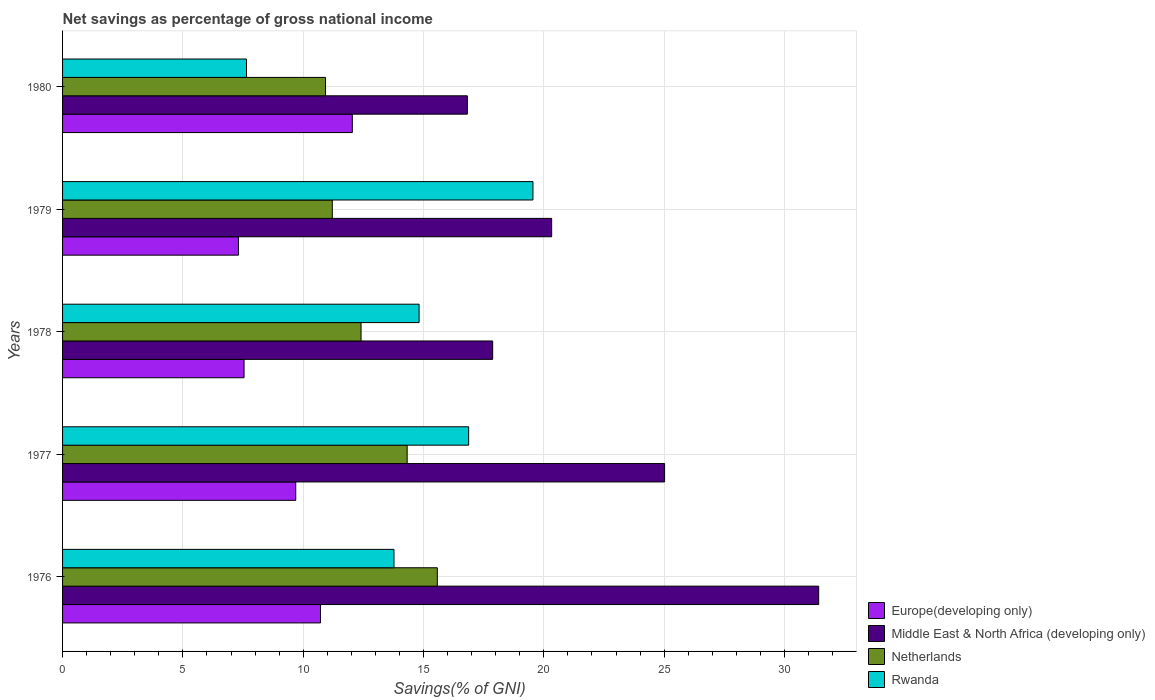How many groups of bars are there?
Make the answer very short. 5. Are the number of bars per tick equal to the number of legend labels?
Your response must be concise. Yes. Are the number of bars on each tick of the Y-axis equal?
Offer a very short reply. Yes. How many bars are there on the 1st tick from the top?
Provide a succinct answer. 4. What is the label of the 1st group of bars from the top?
Offer a terse response. 1980. In how many cases, is the number of bars for a given year not equal to the number of legend labels?
Ensure brevity in your answer.  0. What is the total savings in Middle East & North Africa (developing only) in 1977?
Offer a very short reply. 25.02. Across all years, what is the maximum total savings in Middle East & North Africa (developing only)?
Provide a short and direct response. 31.42. Across all years, what is the minimum total savings in Middle East & North Africa (developing only)?
Provide a succinct answer. 16.82. In which year was the total savings in Netherlands maximum?
Make the answer very short. 1976. In which year was the total savings in Europe(developing only) minimum?
Your answer should be very brief. 1979. What is the total total savings in Middle East & North Africa (developing only) in the graph?
Give a very brief answer. 111.46. What is the difference between the total savings in Middle East & North Africa (developing only) in 1977 and that in 1978?
Your answer should be compact. 7.14. What is the difference between the total savings in Europe(developing only) in 1979 and the total savings in Rwanda in 1980?
Offer a very short reply. -0.33. What is the average total savings in Netherlands per year?
Your answer should be very brief. 12.89. In the year 1978, what is the difference between the total savings in Middle East & North Africa (developing only) and total savings in Netherlands?
Your answer should be very brief. 5.47. What is the ratio of the total savings in Europe(developing only) in 1977 to that in 1978?
Provide a short and direct response. 1.28. Is the difference between the total savings in Middle East & North Africa (developing only) in 1976 and 1979 greater than the difference between the total savings in Netherlands in 1976 and 1979?
Your answer should be compact. Yes. What is the difference between the highest and the second highest total savings in Rwanda?
Your response must be concise. 2.67. What is the difference between the highest and the lowest total savings in Europe(developing only)?
Make the answer very short. 4.73. In how many years, is the total savings in Middle East & North Africa (developing only) greater than the average total savings in Middle East & North Africa (developing only) taken over all years?
Offer a terse response. 2. Is it the case that in every year, the sum of the total savings in Rwanda and total savings in Europe(developing only) is greater than the sum of total savings in Middle East & North Africa (developing only) and total savings in Netherlands?
Offer a very short reply. No. What does the 1st bar from the top in 1977 represents?
Your answer should be very brief. Rwanda. What does the 2nd bar from the bottom in 1978 represents?
Give a very brief answer. Middle East & North Africa (developing only). Is it the case that in every year, the sum of the total savings in Middle East & North Africa (developing only) and total savings in Rwanda is greater than the total savings in Netherlands?
Your answer should be very brief. Yes. Are all the bars in the graph horizontal?
Your answer should be compact. Yes. How many legend labels are there?
Offer a terse response. 4. What is the title of the graph?
Offer a terse response. Net savings as percentage of gross national income. What is the label or title of the X-axis?
Keep it short and to the point. Savings(% of GNI). What is the Savings(% of GNI) of Europe(developing only) in 1976?
Your response must be concise. 10.72. What is the Savings(% of GNI) of Middle East & North Africa (developing only) in 1976?
Ensure brevity in your answer.  31.42. What is the Savings(% of GNI) of Netherlands in 1976?
Your response must be concise. 15.57. What is the Savings(% of GNI) in Rwanda in 1976?
Provide a short and direct response. 13.77. What is the Savings(% of GNI) of Europe(developing only) in 1977?
Make the answer very short. 9.69. What is the Savings(% of GNI) in Middle East & North Africa (developing only) in 1977?
Provide a short and direct response. 25.02. What is the Savings(% of GNI) in Netherlands in 1977?
Your answer should be very brief. 14.32. What is the Savings(% of GNI) in Rwanda in 1977?
Your answer should be very brief. 16.88. What is the Savings(% of GNI) in Europe(developing only) in 1978?
Ensure brevity in your answer.  7.54. What is the Savings(% of GNI) in Middle East & North Africa (developing only) in 1978?
Keep it short and to the point. 17.87. What is the Savings(% of GNI) in Netherlands in 1978?
Your answer should be compact. 12.4. What is the Savings(% of GNI) in Rwanda in 1978?
Your response must be concise. 14.82. What is the Savings(% of GNI) in Europe(developing only) in 1979?
Offer a terse response. 7.31. What is the Savings(% of GNI) of Middle East & North Africa (developing only) in 1979?
Ensure brevity in your answer.  20.32. What is the Savings(% of GNI) in Netherlands in 1979?
Provide a succinct answer. 11.21. What is the Savings(% of GNI) in Rwanda in 1979?
Make the answer very short. 19.55. What is the Savings(% of GNI) in Europe(developing only) in 1980?
Your response must be concise. 12.04. What is the Savings(% of GNI) in Middle East & North Africa (developing only) in 1980?
Offer a very short reply. 16.82. What is the Savings(% of GNI) of Netherlands in 1980?
Keep it short and to the point. 10.93. What is the Savings(% of GNI) of Rwanda in 1980?
Make the answer very short. 7.64. Across all years, what is the maximum Savings(% of GNI) of Europe(developing only)?
Your answer should be compact. 12.04. Across all years, what is the maximum Savings(% of GNI) in Middle East & North Africa (developing only)?
Provide a succinct answer. 31.42. Across all years, what is the maximum Savings(% of GNI) in Netherlands?
Your answer should be very brief. 15.57. Across all years, what is the maximum Savings(% of GNI) of Rwanda?
Make the answer very short. 19.55. Across all years, what is the minimum Savings(% of GNI) of Europe(developing only)?
Keep it short and to the point. 7.31. Across all years, what is the minimum Savings(% of GNI) of Middle East & North Africa (developing only)?
Offer a terse response. 16.82. Across all years, what is the minimum Savings(% of GNI) of Netherlands?
Keep it short and to the point. 10.93. Across all years, what is the minimum Savings(% of GNI) in Rwanda?
Offer a terse response. 7.64. What is the total Savings(% of GNI) in Europe(developing only) in the graph?
Keep it short and to the point. 47.3. What is the total Savings(% of GNI) in Middle East & North Africa (developing only) in the graph?
Offer a very short reply. 111.46. What is the total Savings(% of GNI) of Netherlands in the graph?
Your response must be concise. 64.43. What is the total Savings(% of GNI) of Rwanda in the graph?
Your response must be concise. 72.66. What is the difference between the Savings(% of GNI) of Europe(developing only) in 1976 and that in 1977?
Your answer should be very brief. 1.03. What is the difference between the Savings(% of GNI) of Middle East & North Africa (developing only) in 1976 and that in 1977?
Keep it short and to the point. 6.4. What is the difference between the Savings(% of GNI) in Netherlands in 1976 and that in 1977?
Make the answer very short. 1.25. What is the difference between the Savings(% of GNI) in Rwanda in 1976 and that in 1977?
Your answer should be very brief. -3.1. What is the difference between the Savings(% of GNI) in Europe(developing only) in 1976 and that in 1978?
Keep it short and to the point. 3.18. What is the difference between the Savings(% of GNI) in Middle East & North Africa (developing only) in 1976 and that in 1978?
Provide a succinct answer. 13.55. What is the difference between the Savings(% of GNI) of Netherlands in 1976 and that in 1978?
Provide a short and direct response. 3.17. What is the difference between the Savings(% of GNI) in Rwanda in 1976 and that in 1978?
Provide a short and direct response. -1.04. What is the difference between the Savings(% of GNI) in Europe(developing only) in 1976 and that in 1979?
Make the answer very short. 3.41. What is the difference between the Savings(% of GNI) in Middle East & North Africa (developing only) in 1976 and that in 1979?
Provide a short and direct response. 11.1. What is the difference between the Savings(% of GNI) of Netherlands in 1976 and that in 1979?
Your response must be concise. 4.36. What is the difference between the Savings(% of GNI) in Rwanda in 1976 and that in 1979?
Ensure brevity in your answer.  -5.77. What is the difference between the Savings(% of GNI) in Europe(developing only) in 1976 and that in 1980?
Give a very brief answer. -1.32. What is the difference between the Savings(% of GNI) in Middle East & North Africa (developing only) in 1976 and that in 1980?
Provide a short and direct response. 14.6. What is the difference between the Savings(% of GNI) in Netherlands in 1976 and that in 1980?
Offer a terse response. 4.65. What is the difference between the Savings(% of GNI) in Rwanda in 1976 and that in 1980?
Provide a short and direct response. 6.13. What is the difference between the Savings(% of GNI) of Europe(developing only) in 1977 and that in 1978?
Keep it short and to the point. 2.15. What is the difference between the Savings(% of GNI) of Middle East & North Africa (developing only) in 1977 and that in 1978?
Offer a terse response. 7.14. What is the difference between the Savings(% of GNI) of Netherlands in 1977 and that in 1978?
Your answer should be very brief. 1.92. What is the difference between the Savings(% of GNI) of Rwanda in 1977 and that in 1978?
Give a very brief answer. 2.06. What is the difference between the Savings(% of GNI) of Europe(developing only) in 1977 and that in 1979?
Ensure brevity in your answer.  2.38. What is the difference between the Savings(% of GNI) of Middle East & North Africa (developing only) in 1977 and that in 1979?
Your answer should be compact. 4.69. What is the difference between the Savings(% of GNI) of Netherlands in 1977 and that in 1979?
Provide a succinct answer. 3.11. What is the difference between the Savings(% of GNI) of Rwanda in 1977 and that in 1979?
Make the answer very short. -2.67. What is the difference between the Savings(% of GNI) of Europe(developing only) in 1977 and that in 1980?
Your response must be concise. -2.35. What is the difference between the Savings(% of GNI) in Middle East & North Africa (developing only) in 1977 and that in 1980?
Your answer should be compact. 8.2. What is the difference between the Savings(% of GNI) in Netherlands in 1977 and that in 1980?
Your response must be concise. 3.39. What is the difference between the Savings(% of GNI) of Rwanda in 1977 and that in 1980?
Offer a terse response. 9.23. What is the difference between the Savings(% of GNI) of Europe(developing only) in 1978 and that in 1979?
Keep it short and to the point. 0.23. What is the difference between the Savings(% of GNI) of Middle East & North Africa (developing only) in 1978 and that in 1979?
Offer a terse response. -2.45. What is the difference between the Savings(% of GNI) in Netherlands in 1978 and that in 1979?
Offer a terse response. 1.19. What is the difference between the Savings(% of GNI) of Rwanda in 1978 and that in 1979?
Give a very brief answer. -4.73. What is the difference between the Savings(% of GNI) of Europe(developing only) in 1978 and that in 1980?
Offer a very short reply. -4.5. What is the difference between the Savings(% of GNI) of Middle East & North Africa (developing only) in 1978 and that in 1980?
Give a very brief answer. 1.05. What is the difference between the Savings(% of GNI) in Netherlands in 1978 and that in 1980?
Your response must be concise. 1.48. What is the difference between the Savings(% of GNI) in Rwanda in 1978 and that in 1980?
Provide a succinct answer. 7.17. What is the difference between the Savings(% of GNI) in Europe(developing only) in 1979 and that in 1980?
Your response must be concise. -4.73. What is the difference between the Savings(% of GNI) in Middle East & North Africa (developing only) in 1979 and that in 1980?
Offer a very short reply. 3.5. What is the difference between the Savings(% of GNI) in Netherlands in 1979 and that in 1980?
Give a very brief answer. 0.28. What is the difference between the Savings(% of GNI) in Rwanda in 1979 and that in 1980?
Provide a succinct answer. 11.9. What is the difference between the Savings(% of GNI) of Europe(developing only) in 1976 and the Savings(% of GNI) of Middle East & North Africa (developing only) in 1977?
Offer a terse response. -14.3. What is the difference between the Savings(% of GNI) in Europe(developing only) in 1976 and the Savings(% of GNI) in Netherlands in 1977?
Offer a terse response. -3.6. What is the difference between the Savings(% of GNI) in Europe(developing only) in 1976 and the Savings(% of GNI) in Rwanda in 1977?
Your answer should be very brief. -6.16. What is the difference between the Savings(% of GNI) of Middle East & North Africa (developing only) in 1976 and the Savings(% of GNI) of Netherlands in 1977?
Your answer should be compact. 17.1. What is the difference between the Savings(% of GNI) in Middle East & North Africa (developing only) in 1976 and the Savings(% of GNI) in Rwanda in 1977?
Your answer should be compact. 14.55. What is the difference between the Savings(% of GNI) in Netherlands in 1976 and the Savings(% of GNI) in Rwanda in 1977?
Make the answer very short. -1.3. What is the difference between the Savings(% of GNI) of Europe(developing only) in 1976 and the Savings(% of GNI) of Middle East & North Africa (developing only) in 1978?
Provide a short and direct response. -7.15. What is the difference between the Savings(% of GNI) in Europe(developing only) in 1976 and the Savings(% of GNI) in Netherlands in 1978?
Your answer should be very brief. -1.68. What is the difference between the Savings(% of GNI) of Europe(developing only) in 1976 and the Savings(% of GNI) of Rwanda in 1978?
Provide a short and direct response. -4.1. What is the difference between the Savings(% of GNI) of Middle East & North Africa (developing only) in 1976 and the Savings(% of GNI) of Netherlands in 1978?
Make the answer very short. 19.02. What is the difference between the Savings(% of GNI) in Middle East & North Africa (developing only) in 1976 and the Savings(% of GNI) in Rwanda in 1978?
Keep it short and to the point. 16.61. What is the difference between the Savings(% of GNI) in Netherlands in 1976 and the Savings(% of GNI) in Rwanda in 1978?
Provide a succinct answer. 0.76. What is the difference between the Savings(% of GNI) in Europe(developing only) in 1976 and the Savings(% of GNI) in Middle East & North Africa (developing only) in 1979?
Give a very brief answer. -9.6. What is the difference between the Savings(% of GNI) of Europe(developing only) in 1976 and the Savings(% of GNI) of Netherlands in 1979?
Offer a terse response. -0.49. What is the difference between the Savings(% of GNI) of Europe(developing only) in 1976 and the Savings(% of GNI) of Rwanda in 1979?
Give a very brief answer. -8.83. What is the difference between the Savings(% of GNI) of Middle East & North Africa (developing only) in 1976 and the Savings(% of GNI) of Netherlands in 1979?
Offer a terse response. 20.21. What is the difference between the Savings(% of GNI) of Middle East & North Africa (developing only) in 1976 and the Savings(% of GNI) of Rwanda in 1979?
Keep it short and to the point. 11.87. What is the difference between the Savings(% of GNI) in Netherlands in 1976 and the Savings(% of GNI) in Rwanda in 1979?
Provide a short and direct response. -3.97. What is the difference between the Savings(% of GNI) of Europe(developing only) in 1976 and the Savings(% of GNI) of Middle East & North Africa (developing only) in 1980?
Your answer should be compact. -6.1. What is the difference between the Savings(% of GNI) in Europe(developing only) in 1976 and the Savings(% of GNI) in Netherlands in 1980?
Your answer should be very brief. -0.21. What is the difference between the Savings(% of GNI) in Europe(developing only) in 1976 and the Savings(% of GNI) in Rwanda in 1980?
Your answer should be compact. 3.08. What is the difference between the Savings(% of GNI) of Middle East & North Africa (developing only) in 1976 and the Savings(% of GNI) of Netherlands in 1980?
Ensure brevity in your answer.  20.49. What is the difference between the Savings(% of GNI) of Middle East & North Africa (developing only) in 1976 and the Savings(% of GNI) of Rwanda in 1980?
Ensure brevity in your answer.  23.78. What is the difference between the Savings(% of GNI) in Netherlands in 1976 and the Savings(% of GNI) in Rwanda in 1980?
Provide a succinct answer. 7.93. What is the difference between the Savings(% of GNI) in Europe(developing only) in 1977 and the Savings(% of GNI) in Middle East & North Africa (developing only) in 1978?
Provide a succinct answer. -8.18. What is the difference between the Savings(% of GNI) of Europe(developing only) in 1977 and the Savings(% of GNI) of Netherlands in 1978?
Keep it short and to the point. -2.71. What is the difference between the Savings(% of GNI) in Europe(developing only) in 1977 and the Savings(% of GNI) in Rwanda in 1978?
Offer a very short reply. -5.13. What is the difference between the Savings(% of GNI) of Middle East & North Africa (developing only) in 1977 and the Savings(% of GNI) of Netherlands in 1978?
Offer a terse response. 12.62. What is the difference between the Savings(% of GNI) of Middle East & North Africa (developing only) in 1977 and the Savings(% of GNI) of Rwanda in 1978?
Keep it short and to the point. 10.2. What is the difference between the Savings(% of GNI) of Netherlands in 1977 and the Savings(% of GNI) of Rwanda in 1978?
Keep it short and to the point. -0.5. What is the difference between the Savings(% of GNI) in Europe(developing only) in 1977 and the Savings(% of GNI) in Middle East & North Africa (developing only) in 1979?
Offer a very short reply. -10.63. What is the difference between the Savings(% of GNI) of Europe(developing only) in 1977 and the Savings(% of GNI) of Netherlands in 1979?
Provide a succinct answer. -1.52. What is the difference between the Savings(% of GNI) of Europe(developing only) in 1977 and the Savings(% of GNI) of Rwanda in 1979?
Offer a terse response. -9.86. What is the difference between the Savings(% of GNI) in Middle East & North Africa (developing only) in 1977 and the Savings(% of GNI) in Netherlands in 1979?
Provide a succinct answer. 13.81. What is the difference between the Savings(% of GNI) in Middle East & North Africa (developing only) in 1977 and the Savings(% of GNI) in Rwanda in 1979?
Your answer should be very brief. 5.47. What is the difference between the Savings(% of GNI) in Netherlands in 1977 and the Savings(% of GNI) in Rwanda in 1979?
Keep it short and to the point. -5.23. What is the difference between the Savings(% of GNI) of Europe(developing only) in 1977 and the Savings(% of GNI) of Middle East & North Africa (developing only) in 1980?
Give a very brief answer. -7.13. What is the difference between the Savings(% of GNI) of Europe(developing only) in 1977 and the Savings(% of GNI) of Netherlands in 1980?
Your response must be concise. -1.24. What is the difference between the Savings(% of GNI) of Europe(developing only) in 1977 and the Savings(% of GNI) of Rwanda in 1980?
Your answer should be very brief. 2.05. What is the difference between the Savings(% of GNI) of Middle East & North Africa (developing only) in 1977 and the Savings(% of GNI) of Netherlands in 1980?
Offer a terse response. 14.09. What is the difference between the Savings(% of GNI) in Middle East & North Africa (developing only) in 1977 and the Savings(% of GNI) in Rwanda in 1980?
Give a very brief answer. 17.37. What is the difference between the Savings(% of GNI) of Netherlands in 1977 and the Savings(% of GNI) of Rwanda in 1980?
Your answer should be compact. 6.68. What is the difference between the Savings(% of GNI) of Europe(developing only) in 1978 and the Savings(% of GNI) of Middle East & North Africa (developing only) in 1979?
Give a very brief answer. -12.78. What is the difference between the Savings(% of GNI) in Europe(developing only) in 1978 and the Savings(% of GNI) in Netherlands in 1979?
Your answer should be very brief. -3.67. What is the difference between the Savings(% of GNI) in Europe(developing only) in 1978 and the Savings(% of GNI) in Rwanda in 1979?
Make the answer very short. -12.01. What is the difference between the Savings(% of GNI) of Middle East & North Africa (developing only) in 1978 and the Savings(% of GNI) of Netherlands in 1979?
Give a very brief answer. 6.66. What is the difference between the Savings(% of GNI) in Middle East & North Africa (developing only) in 1978 and the Savings(% of GNI) in Rwanda in 1979?
Provide a succinct answer. -1.67. What is the difference between the Savings(% of GNI) of Netherlands in 1978 and the Savings(% of GNI) of Rwanda in 1979?
Provide a succinct answer. -7.14. What is the difference between the Savings(% of GNI) in Europe(developing only) in 1978 and the Savings(% of GNI) in Middle East & North Africa (developing only) in 1980?
Offer a terse response. -9.28. What is the difference between the Savings(% of GNI) of Europe(developing only) in 1978 and the Savings(% of GNI) of Netherlands in 1980?
Give a very brief answer. -3.39. What is the difference between the Savings(% of GNI) in Europe(developing only) in 1978 and the Savings(% of GNI) in Rwanda in 1980?
Keep it short and to the point. -0.1. What is the difference between the Savings(% of GNI) in Middle East & North Africa (developing only) in 1978 and the Savings(% of GNI) in Netherlands in 1980?
Your response must be concise. 6.95. What is the difference between the Savings(% of GNI) of Middle East & North Africa (developing only) in 1978 and the Savings(% of GNI) of Rwanda in 1980?
Make the answer very short. 10.23. What is the difference between the Savings(% of GNI) of Netherlands in 1978 and the Savings(% of GNI) of Rwanda in 1980?
Offer a very short reply. 4.76. What is the difference between the Savings(% of GNI) in Europe(developing only) in 1979 and the Savings(% of GNI) in Middle East & North Africa (developing only) in 1980?
Keep it short and to the point. -9.51. What is the difference between the Savings(% of GNI) of Europe(developing only) in 1979 and the Savings(% of GNI) of Netherlands in 1980?
Your response must be concise. -3.62. What is the difference between the Savings(% of GNI) in Europe(developing only) in 1979 and the Savings(% of GNI) in Rwanda in 1980?
Give a very brief answer. -0.33. What is the difference between the Savings(% of GNI) of Middle East & North Africa (developing only) in 1979 and the Savings(% of GNI) of Netherlands in 1980?
Your answer should be compact. 9.4. What is the difference between the Savings(% of GNI) of Middle East & North Africa (developing only) in 1979 and the Savings(% of GNI) of Rwanda in 1980?
Ensure brevity in your answer.  12.68. What is the difference between the Savings(% of GNI) in Netherlands in 1979 and the Savings(% of GNI) in Rwanda in 1980?
Offer a very short reply. 3.57. What is the average Savings(% of GNI) of Europe(developing only) per year?
Provide a succinct answer. 9.46. What is the average Savings(% of GNI) in Middle East & North Africa (developing only) per year?
Give a very brief answer. 22.29. What is the average Savings(% of GNI) in Netherlands per year?
Your answer should be very brief. 12.89. What is the average Savings(% of GNI) of Rwanda per year?
Keep it short and to the point. 14.53. In the year 1976, what is the difference between the Savings(% of GNI) in Europe(developing only) and Savings(% of GNI) in Middle East & North Africa (developing only)?
Ensure brevity in your answer.  -20.7. In the year 1976, what is the difference between the Savings(% of GNI) of Europe(developing only) and Savings(% of GNI) of Netherlands?
Your answer should be compact. -4.85. In the year 1976, what is the difference between the Savings(% of GNI) in Europe(developing only) and Savings(% of GNI) in Rwanda?
Your answer should be very brief. -3.05. In the year 1976, what is the difference between the Savings(% of GNI) of Middle East & North Africa (developing only) and Savings(% of GNI) of Netherlands?
Your response must be concise. 15.85. In the year 1976, what is the difference between the Savings(% of GNI) of Middle East & North Africa (developing only) and Savings(% of GNI) of Rwanda?
Keep it short and to the point. 17.65. In the year 1976, what is the difference between the Savings(% of GNI) in Netherlands and Savings(% of GNI) in Rwanda?
Offer a terse response. 1.8. In the year 1977, what is the difference between the Savings(% of GNI) in Europe(developing only) and Savings(% of GNI) in Middle East & North Africa (developing only)?
Your response must be concise. -15.33. In the year 1977, what is the difference between the Savings(% of GNI) of Europe(developing only) and Savings(% of GNI) of Netherlands?
Your answer should be very brief. -4.63. In the year 1977, what is the difference between the Savings(% of GNI) in Europe(developing only) and Savings(% of GNI) in Rwanda?
Keep it short and to the point. -7.18. In the year 1977, what is the difference between the Savings(% of GNI) in Middle East & North Africa (developing only) and Savings(% of GNI) in Netherlands?
Provide a short and direct response. 10.7. In the year 1977, what is the difference between the Savings(% of GNI) of Middle East & North Africa (developing only) and Savings(% of GNI) of Rwanda?
Provide a short and direct response. 8.14. In the year 1977, what is the difference between the Savings(% of GNI) in Netherlands and Savings(% of GNI) in Rwanda?
Provide a short and direct response. -2.56. In the year 1978, what is the difference between the Savings(% of GNI) in Europe(developing only) and Savings(% of GNI) in Middle East & North Africa (developing only)?
Offer a terse response. -10.33. In the year 1978, what is the difference between the Savings(% of GNI) of Europe(developing only) and Savings(% of GNI) of Netherlands?
Your answer should be compact. -4.86. In the year 1978, what is the difference between the Savings(% of GNI) of Europe(developing only) and Savings(% of GNI) of Rwanda?
Ensure brevity in your answer.  -7.27. In the year 1978, what is the difference between the Savings(% of GNI) in Middle East & North Africa (developing only) and Savings(% of GNI) in Netherlands?
Provide a succinct answer. 5.47. In the year 1978, what is the difference between the Savings(% of GNI) of Middle East & North Africa (developing only) and Savings(% of GNI) of Rwanda?
Give a very brief answer. 3.06. In the year 1978, what is the difference between the Savings(% of GNI) in Netherlands and Savings(% of GNI) in Rwanda?
Provide a short and direct response. -2.41. In the year 1979, what is the difference between the Savings(% of GNI) in Europe(developing only) and Savings(% of GNI) in Middle East & North Africa (developing only)?
Provide a short and direct response. -13.02. In the year 1979, what is the difference between the Savings(% of GNI) in Europe(developing only) and Savings(% of GNI) in Netherlands?
Ensure brevity in your answer.  -3.9. In the year 1979, what is the difference between the Savings(% of GNI) of Europe(developing only) and Savings(% of GNI) of Rwanda?
Your response must be concise. -12.24. In the year 1979, what is the difference between the Savings(% of GNI) in Middle East & North Africa (developing only) and Savings(% of GNI) in Netherlands?
Offer a very short reply. 9.12. In the year 1979, what is the difference between the Savings(% of GNI) of Middle East & North Africa (developing only) and Savings(% of GNI) of Rwanda?
Ensure brevity in your answer.  0.78. In the year 1979, what is the difference between the Savings(% of GNI) of Netherlands and Savings(% of GNI) of Rwanda?
Keep it short and to the point. -8.34. In the year 1980, what is the difference between the Savings(% of GNI) of Europe(developing only) and Savings(% of GNI) of Middle East & North Africa (developing only)?
Keep it short and to the point. -4.78. In the year 1980, what is the difference between the Savings(% of GNI) in Europe(developing only) and Savings(% of GNI) in Netherlands?
Your response must be concise. 1.11. In the year 1980, what is the difference between the Savings(% of GNI) in Europe(developing only) and Savings(% of GNI) in Rwanda?
Offer a very short reply. 4.4. In the year 1980, what is the difference between the Savings(% of GNI) in Middle East & North Africa (developing only) and Savings(% of GNI) in Netherlands?
Make the answer very short. 5.89. In the year 1980, what is the difference between the Savings(% of GNI) of Middle East & North Africa (developing only) and Savings(% of GNI) of Rwanda?
Your answer should be very brief. 9.18. In the year 1980, what is the difference between the Savings(% of GNI) of Netherlands and Savings(% of GNI) of Rwanda?
Make the answer very short. 3.28. What is the ratio of the Savings(% of GNI) of Europe(developing only) in 1976 to that in 1977?
Your answer should be compact. 1.11. What is the ratio of the Savings(% of GNI) of Middle East & North Africa (developing only) in 1976 to that in 1977?
Your answer should be compact. 1.26. What is the ratio of the Savings(% of GNI) in Netherlands in 1976 to that in 1977?
Offer a terse response. 1.09. What is the ratio of the Savings(% of GNI) in Rwanda in 1976 to that in 1977?
Your response must be concise. 0.82. What is the ratio of the Savings(% of GNI) of Europe(developing only) in 1976 to that in 1978?
Keep it short and to the point. 1.42. What is the ratio of the Savings(% of GNI) in Middle East & North Africa (developing only) in 1976 to that in 1978?
Your answer should be compact. 1.76. What is the ratio of the Savings(% of GNI) in Netherlands in 1976 to that in 1978?
Give a very brief answer. 1.26. What is the ratio of the Savings(% of GNI) in Rwanda in 1976 to that in 1978?
Make the answer very short. 0.93. What is the ratio of the Savings(% of GNI) in Europe(developing only) in 1976 to that in 1979?
Ensure brevity in your answer.  1.47. What is the ratio of the Savings(% of GNI) of Middle East & North Africa (developing only) in 1976 to that in 1979?
Your answer should be compact. 1.55. What is the ratio of the Savings(% of GNI) of Netherlands in 1976 to that in 1979?
Give a very brief answer. 1.39. What is the ratio of the Savings(% of GNI) in Rwanda in 1976 to that in 1979?
Provide a succinct answer. 0.7. What is the ratio of the Savings(% of GNI) in Europe(developing only) in 1976 to that in 1980?
Make the answer very short. 0.89. What is the ratio of the Savings(% of GNI) in Middle East & North Africa (developing only) in 1976 to that in 1980?
Give a very brief answer. 1.87. What is the ratio of the Savings(% of GNI) of Netherlands in 1976 to that in 1980?
Offer a very short reply. 1.43. What is the ratio of the Savings(% of GNI) of Rwanda in 1976 to that in 1980?
Give a very brief answer. 1.8. What is the ratio of the Savings(% of GNI) in Europe(developing only) in 1977 to that in 1978?
Provide a succinct answer. 1.28. What is the ratio of the Savings(% of GNI) in Middle East & North Africa (developing only) in 1977 to that in 1978?
Keep it short and to the point. 1.4. What is the ratio of the Savings(% of GNI) in Netherlands in 1977 to that in 1978?
Give a very brief answer. 1.15. What is the ratio of the Savings(% of GNI) of Rwanda in 1977 to that in 1978?
Give a very brief answer. 1.14. What is the ratio of the Savings(% of GNI) in Europe(developing only) in 1977 to that in 1979?
Ensure brevity in your answer.  1.33. What is the ratio of the Savings(% of GNI) in Middle East & North Africa (developing only) in 1977 to that in 1979?
Provide a succinct answer. 1.23. What is the ratio of the Savings(% of GNI) in Netherlands in 1977 to that in 1979?
Make the answer very short. 1.28. What is the ratio of the Savings(% of GNI) of Rwanda in 1977 to that in 1979?
Make the answer very short. 0.86. What is the ratio of the Savings(% of GNI) in Europe(developing only) in 1977 to that in 1980?
Your answer should be very brief. 0.8. What is the ratio of the Savings(% of GNI) in Middle East & North Africa (developing only) in 1977 to that in 1980?
Offer a very short reply. 1.49. What is the ratio of the Savings(% of GNI) of Netherlands in 1977 to that in 1980?
Keep it short and to the point. 1.31. What is the ratio of the Savings(% of GNI) in Rwanda in 1977 to that in 1980?
Ensure brevity in your answer.  2.21. What is the ratio of the Savings(% of GNI) of Europe(developing only) in 1978 to that in 1979?
Your answer should be very brief. 1.03. What is the ratio of the Savings(% of GNI) of Middle East & North Africa (developing only) in 1978 to that in 1979?
Ensure brevity in your answer.  0.88. What is the ratio of the Savings(% of GNI) of Netherlands in 1978 to that in 1979?
Provide a short and direct response. 1.11. What is the ratio of the Savings(% of GNI) in Rwanda in 1978 to that in 1979?
Give a very brief answer. 0.76. What is the ratio of the Savings(% of GNI) of Europe(developing only) in 1978 to that in 1980?
Your answer should be very brief. 0.63. What is the ratio of the Savings(% of GNI) in Middle East & North Africa (developing only) in 1978 to that in 1980?
Ensure brevity in your answer.  1.06. What is the ratio of the Savings(% of GNI) in Netherlands in 1978 to that in 1980?
Offer a very short reply. 1.14. What is the ratio of the Savings(% of GNI) of Rwanda in 1978 to that in 1980?
Keep it short and to the point. 1.94. What is the ratio of the Savings(% of GNI) of Europe(developing only) in 1979 to that in 1980?
Your answer should be very brief. 0.61. What is the ratio of the Savings(% of GNI) of Middle East & North Africa (developing only) in 1979 to that in 1980?
Provide a short and direct response. 1.21. What is the ratio of the Savings(% of GNI) of Netherlands in 1979 to that in 1980?
Your answer should be compact. 1.03. What is the ratio of the Savings(% of GNI) in Rwanda in 1979 to that in 1980?
Offer a very short reply. 2.56. What is the difference between the highest and the second highest Savings(% of GNI) of Europe(developing only)?
Your answer should be very brief. 1.32. What is the difference between the highest and the second highest Savings(% of GNI) of Middle East & North Africa (developing only)?
Your response must be concise. 6.4. What is the difference between the highest and the second highest Savings(% of GNI) in Netherlands?
Give a very brief answer. 1.25. What is the difference between the highest and the second highest Savings(% of GNI) of Rwanda?
Your answer should be very brief. 2.67. What is the difference between the highest and the lowest Savings(% of GNI) of Europe(developing only)?
Give a very brief answer. 4.73. What is the difference between the highest and the lowest Savings(% of GNI) in Middle East & North Africa (developing only)?
Your response must be concise. 14.6. What is the difference between the highest and the lowest Savings(% of GNI) of Netherlands?
Provide a succinct answer. 4.65. What is the difference between the highest and the lowest Savings(% of GNI) of Rwanda?
Your answer should be very brief. 11.9. 